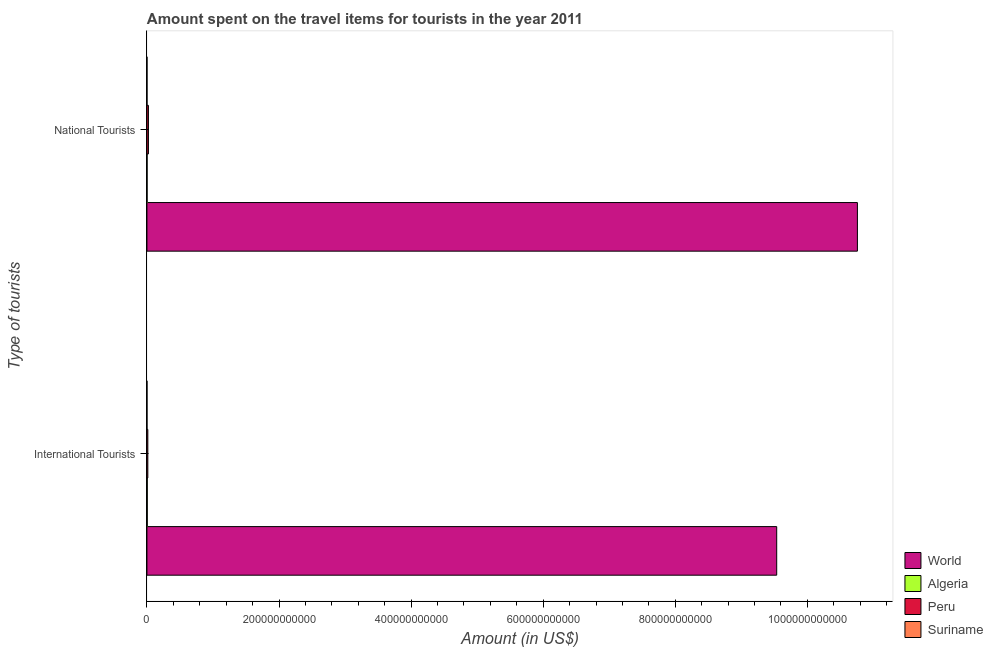How many different coloured bars are there?
Give a very brief answer. 4. How many groups of bars are there?
Ensure brevity in your answer.  2. Are the number of bars per tick equal to the number of legend labels?
Your response must be concise. Yes. Are the number of bars on each tick of the Y-axis equal?
Ensure brevity in your answer.  Yes. What is the label of the 1st group of bars from the top?
Your answer should be compact. National Tourists. What is the amount spent on travel items of international tourists in Algeria?
Keep it short and to the point. 5.02e+08. Across all countries, what is the maximum amount spent on travel items of national tourists?
Offer a terse response. 1.08e+12. Across all countries, what is the minimum amount spent on travel items of international tourists?
Your answer should be compact. 4.20e+07. In which country was the amount spent on travel items of international tourists maximum?
Provide a succinct answer. World. In which country was the amount spent on travel items of national tourists minimum?
Your response must be concise. Suriname. What is the total amount spent on travel items of national tourists in the graph?
Ensure brevity in your answer.  1.08e+12. What is the difference between the amount spent on travel items of national tourists in Suriname and that in Peru?
Provide a succinct answer. -2.20e+09. What is the difference between the amount spent on travel items of national tourists in Suriname and the amount spent on travel items of international tourists in World?
Keep it short and to the point. -9.54e+11. What is the average amount spent on travel items of national tourists per country?
Your answer should be very brief. 2.70e+11. What is the difference between the amount spent on travel items of national tourists and amount spent on travel items of international tourists in Peru?
Your response must be concise. 9.06e+08. What is the ratio of the amount spent on travel items of international tourists in Suriname to that in Peru?
Provide a short and direct response. 0.03. Is the amount spent on travel items of national tourists in Suriname less than that in World?
Offer a very short reply. Yes. What does the 3rd bar from the top in International Tourists represents?
Make the answer very short. Algeria. Are all the bars in the graph horizontal?
Your answer should be compact. Yes. How many countries are there in the graph?
Give a very brief answer. 4. What is the difference between two consecutive major ticks on the X-axis?
Give a very brief answer. 2.00e+11. Does the graph contain any zero values?
Ensure brevity in your answer.  No. What is the title of the graph?
Make the answer very short. Amount spent on the travel items for tourists in the year 2011. Does "Northern Mariana Islands" appear as one of the legend labels in the graph?
Your answer should be compact. No. What is the label or title of the X-axis?
Provide a succinct answer. Amount (in US$). What is the label or title of the Y-axis?
Keep it short and to the point. Type of tourists. What is the Amount (in US$) of World in International Tourists?
Offer a terse response. 9.54e+11. What is the Amount (in US$) in Algeria in International Tourists?
Provide a succinct answer. 5.02e+08. What is the Amount (in US$) of Peru in International Tourists?
Keep it short and to the point. 1.36e+09. What is the Amount (in US$) of Suriname in International Tourists?
Give a very brief answer. 4.20e+07. What is the Amount (in US$) of World in National Tourists?
Offer a terse response. 1.08e+12. What is the Amount (in US$) of Algeria in National Tourists?
Ensure brevity in your answer.  2.09e+08. What is the Amount (in US$) in Peru in National Tourists?
Offer a terse response. 2.26e+09. What is the Amount (in US$) in Suriname in National Tourists?
Make the answer very short. 6.10e+07. Across all Type of tourists, what is the maximum Amount (in US$) of World?
Ensure brevity in your answer.  1.08e+12. Across all Type of tourists, what is the maximum Amount (in US$) in Algeria?
Provide a succinct answer. 5.02e+08. Across all Type of tourists, what is the maximum Amount (in US$) of Peru?
Your answer should be very brief. 2.26e+09. Across all Type of tourists, what is the maximum Amount (in US$) in Suriname?
Your answer should be compact. 6.10e+07. Across all Type of tourists, what is the minimum Amount (in US$) in World?
Offer a very short reply. 9.54e+11. Across all Type of tourists, what is the minimum Amount (in US$) in Algeria?
Your answer should be very brief. 2.09e+08. Across all Type of tourists, what is the minimum Amount (in US$) in Peru?
Make the answer very short. 1.36e+09. Across all Type of tourists, what is the minimum Amount (in US$) of Suriname?
Provide a short and direct response. 4.20e+07. What is the total Amount (in US$) in World in the graph?
Your answer should be very brief. 2.03e+12. What is the total Amount (in US$) in Algeria in the graph?
Your response must be concise. 7.11e+08. What is the total Amount (in US$) in Peru in the graph?
Keep it short and to the point. 3.62e+09. What is the total Amount (in US$) in Suriname in the graph?
Your response must be concise. 1.03e+08. What is the difference between the Amount (in US$) in World in International Tourists and that in National Tourists?
Give a very brief answer. -1.22e+11. What is the difference between the Amount (in US$) of Algeria in International Tourists and that in National Tourists?
Your response must be concise. 2.93e+08. What is the difference between the Amount (in US$) in Peru in International Tourists and that in National Tourists?
Provide a succinct answer. -9.06e+08. What is the difference between the Amount (in US$) of Suriname in International Tourists and that in National Tourists?
Offer a very short reply. -1.90e+07. What is the difference between the Amount (in US$) of World in International Tourists and the Amount (in US$) of Algeria in National Tourists?
Provide a succinct answer. 9.53e+11. What is the difference between the Amount (in US$) in World in International Tourists and the Amount (in US$) in Peru in National Tourists?
Provide a succinct answer. 9.51e+11. What is the difference between the Amount (in US$) in World in International Tourists and the Amount (in US$) in Suriname in National Tourists?
Provide a short and direct response. 9.54e+11. What is the difference between the Amount (in US$) in Algeria in International Tourists and the Amount (in US$) in Peru in National Tourists?
Offer a very short reply. -1.76e+09. What is the difference between the Amount (in US$) of Algeria in International Tourists and the Amount (in US$) of Suriname in National Tourists?
Ensure brevity in your answer.  4.41e+08. What is the difference between the Amount (in US$) of Peru in International Tourists and the Amount (in US$) of Suriname in National Tourists?
Make the answer very short. 1.30e+09. What is the average Amount (in US$) of World per Type of tourists?
Make the answer very short. 1.01e+12. What is the average Amount (in US$) in Algeria per Type of tourists?
Provide a succinct answer. 3.56e+08. What is the average Amount (in US$) of Peru per Type of tourists?
Provide a succinct answer. 1.81e+09. What is the average Amount (in US$) in Suriname per Type of tourists?
Provide a short and direct response. 5.15e+07. What is the difference between the Amount (in US$) in World and Amount (in US$) in Algeria in International Tourists?
Ensure brevity in your answer.  9.53e+11. What is the difference between the Amount (in US$) in World and Amount (in US$) in Peru in International Tourists?
Your response must be concise. 9.52e+11. What is the difference between the Amount (in US$) of World and Amount (in US$) of Suriname in International Tourists?
Your answer should be compact. 9.54e+11. What is the difference between the Amount (in US$) in Algeria and Amount (in US$) in Peru in International Tourists?
Make the answer very short. -8.54e+08. What is the difference between the Amount (in US$) of Algeria and Amount (in US$) of Suriname in International Tourists?
Your answer should be very brief. 4.60e+08. What is the difference between the Amount (in US$) in Peru and Amount (in US$) in Suriname in International Tourists?
Offer a very short reply. 1.31e+09. What is the difference between the Amount (in US$) of World and Amount (in US$) of Algeria in National Tourists?
Your answer should be very brief. 1.08e+12. What is the difference between the Amount (in US$) in World and Amount (in US$) in Peru in National Tourists?
Make the answer very short. 1.07e+12. What is the difference between the Amount (in US$) of World and Amount (in US$) of Suriname in National Tourists?
Provide a succinct answer. 1.08e+12. What is the difference between the Amount (in US$) in Algeria and Amount (in US$) in Peru in National Tourists?
Ensure brevity in your answer.  -2.05e+09. What is the difference between the Amount (in US$) in Algeria and Amount (in US$) in Suriname in National Tourists?
Offer a terse response. 1.48e+08. What is the difference between the Amount (in US$) in Peru and Amount (in US$) in Suriname in National Tourists?
Provide a short and direct response. 2.20e+09. What is the ratio of the Amount (in US$) of World in International Tourists to that in National Tourists?
Offer a very short reply. 0.89. What is the ratio of the Amount (in US$) of Algeria in International Tourists to that in National Tourists?
Make the answer very short. 2.4. What is the ratio of the Amount (in US$) in Peru in International Tourists to that in National Tourists?
Provide a succinct answer. 0.6. What is the ratio of the Amount (in US$) in Suriname in International Tourists to that in National Tourists?
Keep it short and to the point. 0.69. What is the difference between the highest and the second highest Amount (in US$) in World?
Provide a succinct answer. 1.22e+11. What is the difference between the highest and the second highest Amount (in US$) of Algeria?
Provide a short and direct response. 2.93e+08. What is the difference between the highest and the second highest Amount (in US$) in Peru?
Ensure brevity in your answer.  9.06e+08. What is the difference between the highest and the second highest Amount (in US$) of Suriname?
Your response must be concise. 1.90e+07. What is the difference between the highest and the lowest Amount (in US$) in World?
Ensure brevity in your answer.  1.22e+11. What is the difference between the highest and the lowest Amount (in US$) in Algeria?
Offer a very short reply. 2.93e+08. What is the difference between the highest and the lowest Amount (in US$) in Peru?
Ensure brevity in your answer.  9.06e+08. What is the difference between the highest and the lowest Amount (in US$) of Suriname?
Give a very brief answer. 1.90e+07. 